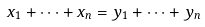Convert formula to latex. <formula><loc_0><loc_0><loc_500><loc_500>x _ { 1 } + \cdots + x _ { n } = y _ { 1 } + \cdots + y _ { n }</formula> 